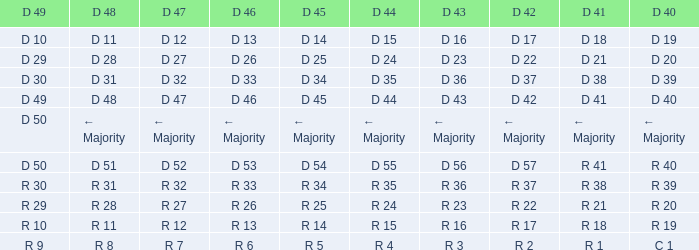Can you provide the d 49 and d 46 for r 13? R 10. 